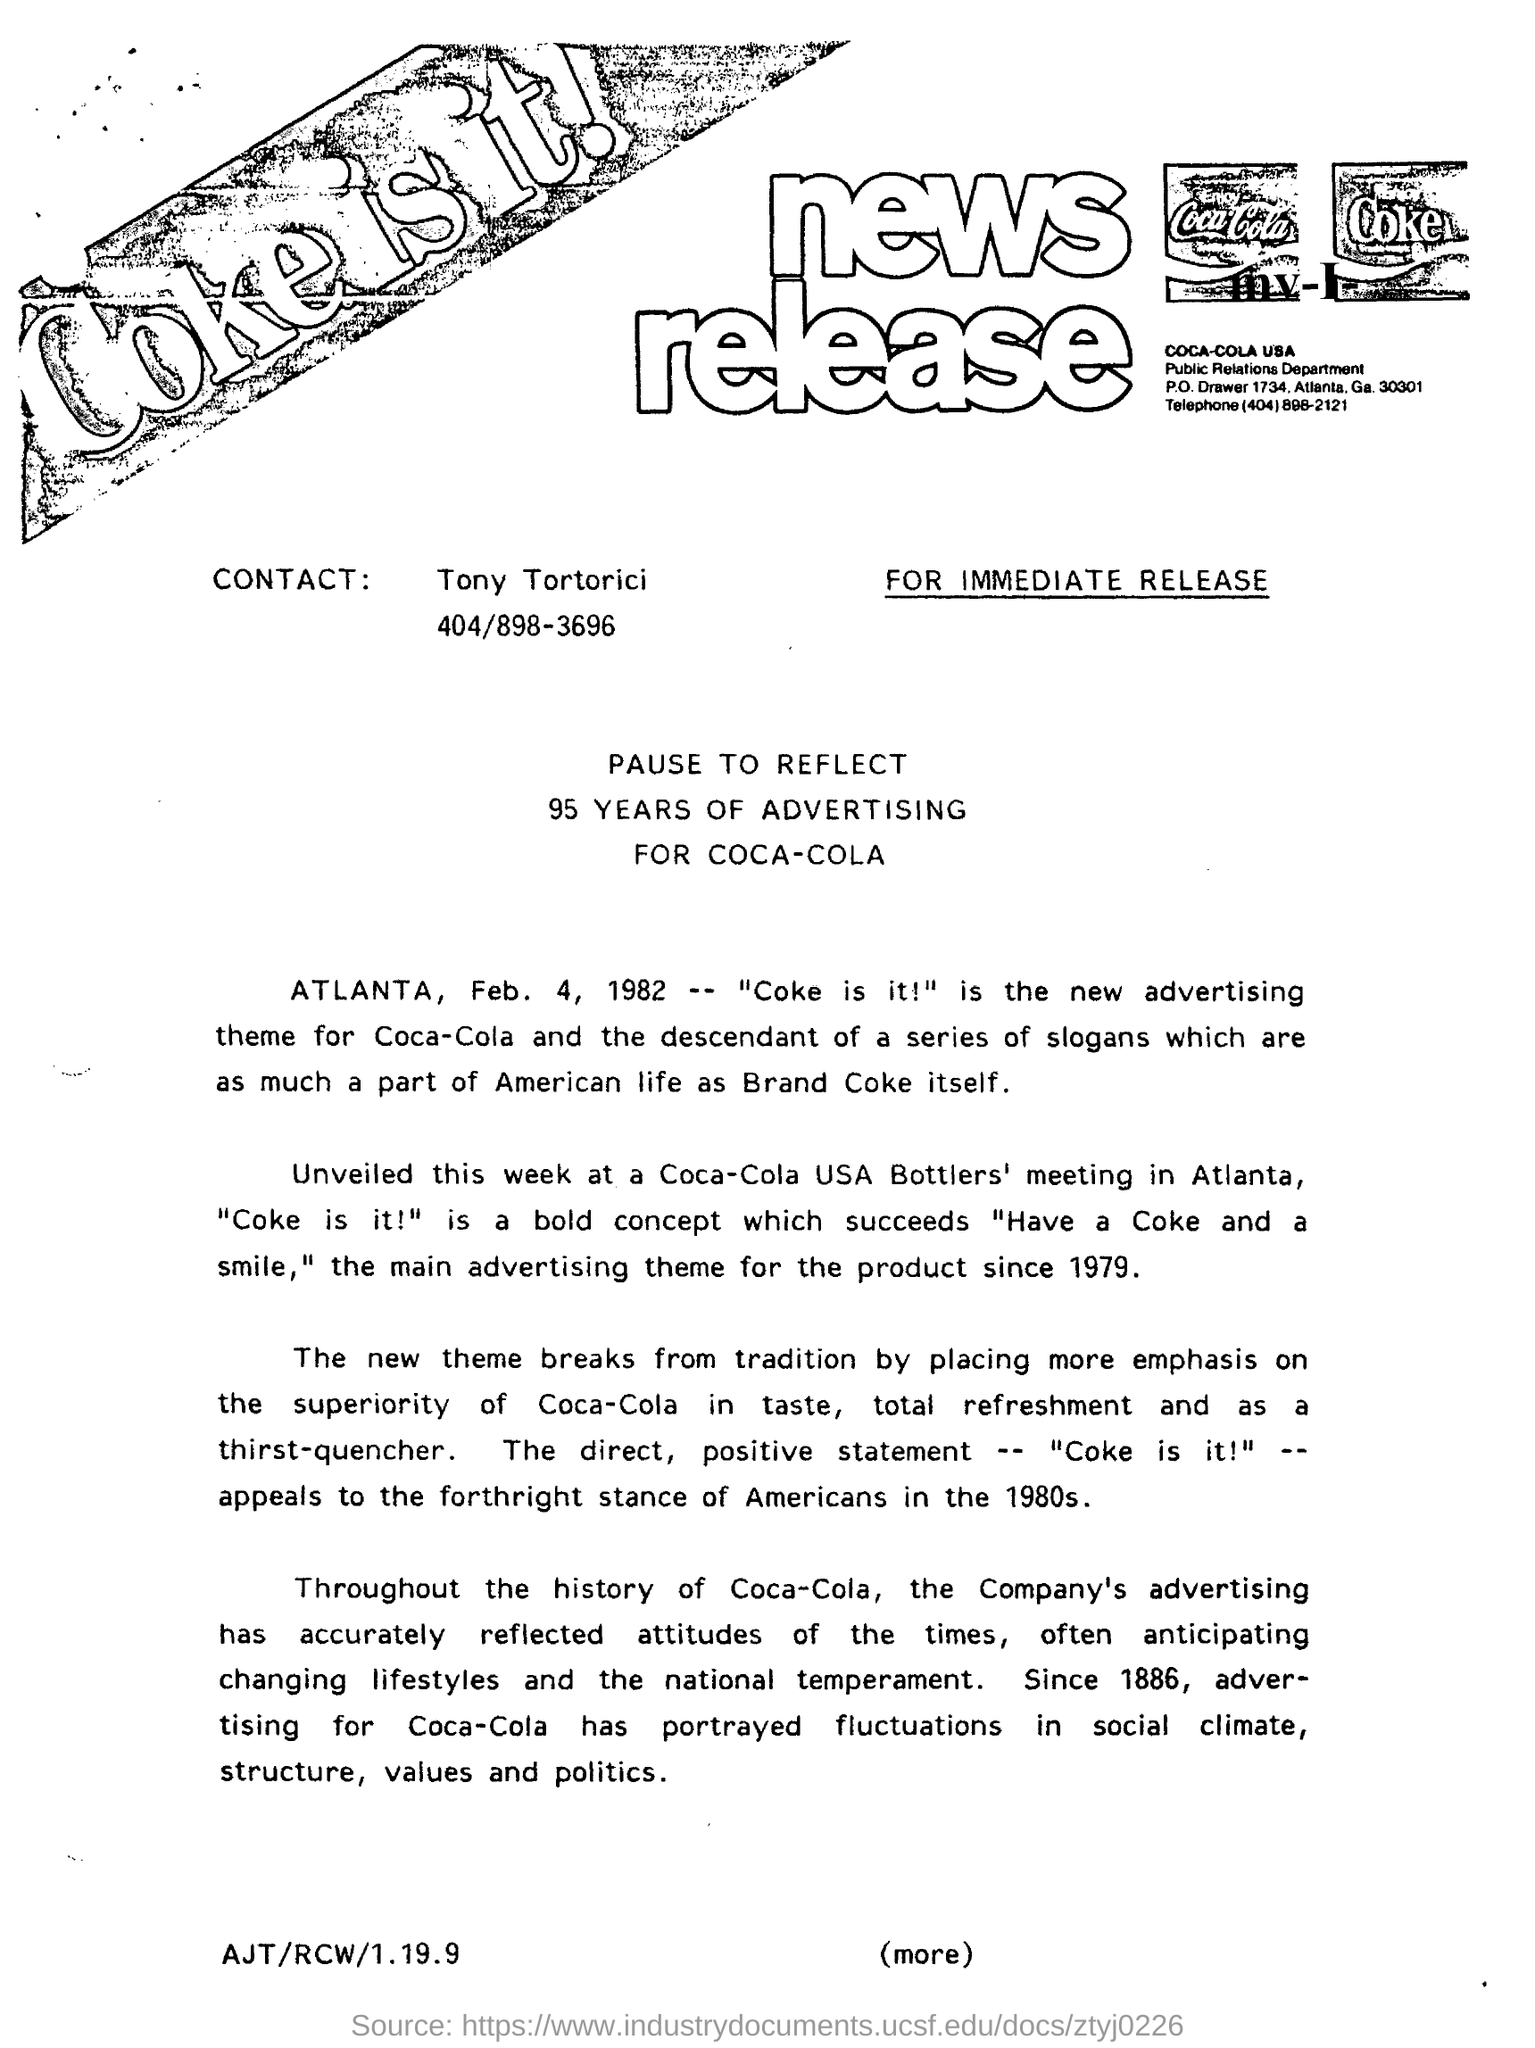Outline some significant characteristics in this image. The name of Tony Tortorici is mentioned in connection with Contact. There is a mention of advertising for 95 years in the text. The date mentioned is February 4, 1982. 